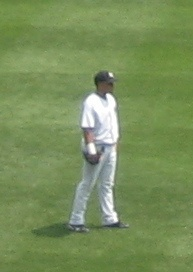Describe the objects in this image and their specific colors. I can see people in green, darkgray, white, and gray tones and baseball glove in green, gray, and black tones in this image. 